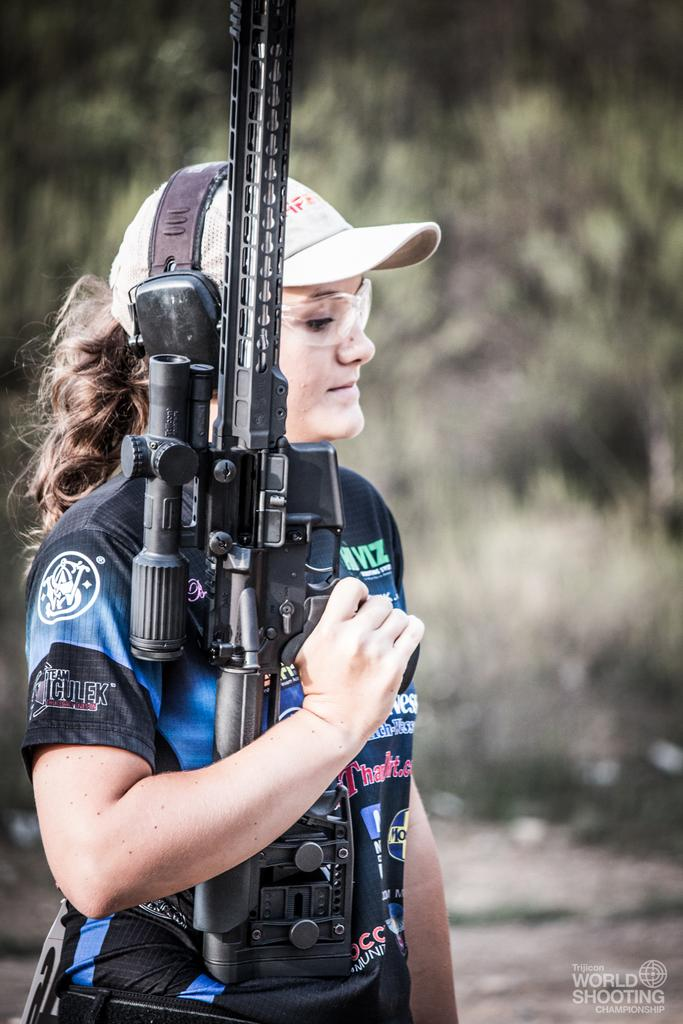What is the main subject of the image? There is a person in the image. Can you describe the background of the image? The background of the image is blurred. What is the person in the image holding in their hand? The person is holding a gun in their hand. What type of spade can be seen being used by the person in the image? There is no spade present in the image; the person is holding a gun. Can you tell me how many apples are visible in the image? There are no apples present in the image. How many men are visible in the image? The image only shows one person, so it cannot be determined if they are a man or not. 